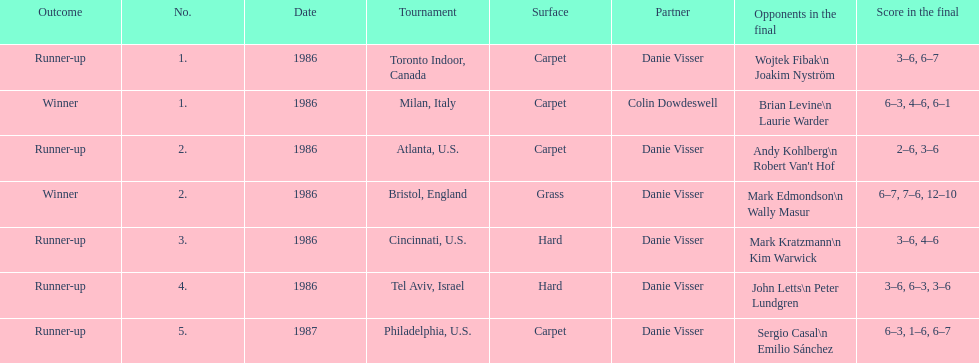What is the combined sum of grass and hard surfaces mentioned? 3. 